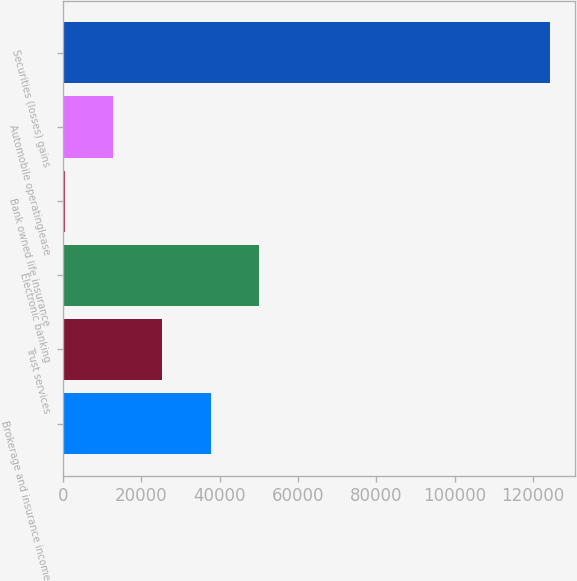Convert chart. <chart><loc_0><loc_0><loc_500><loc_500><bar_chart><fcel>Brokerage and insurance income<fcel>Trust services<fcel>Electronic banking<fcel>Bank owned life insurance<fcel>Automobile operatinglease<fcel>Securities (losses) gains<nl><fcel>37678.6<fcel>25278.4<fcel>50078.8<fcel>478<fcel>12878.2<fcel>124480<nl></chart> 